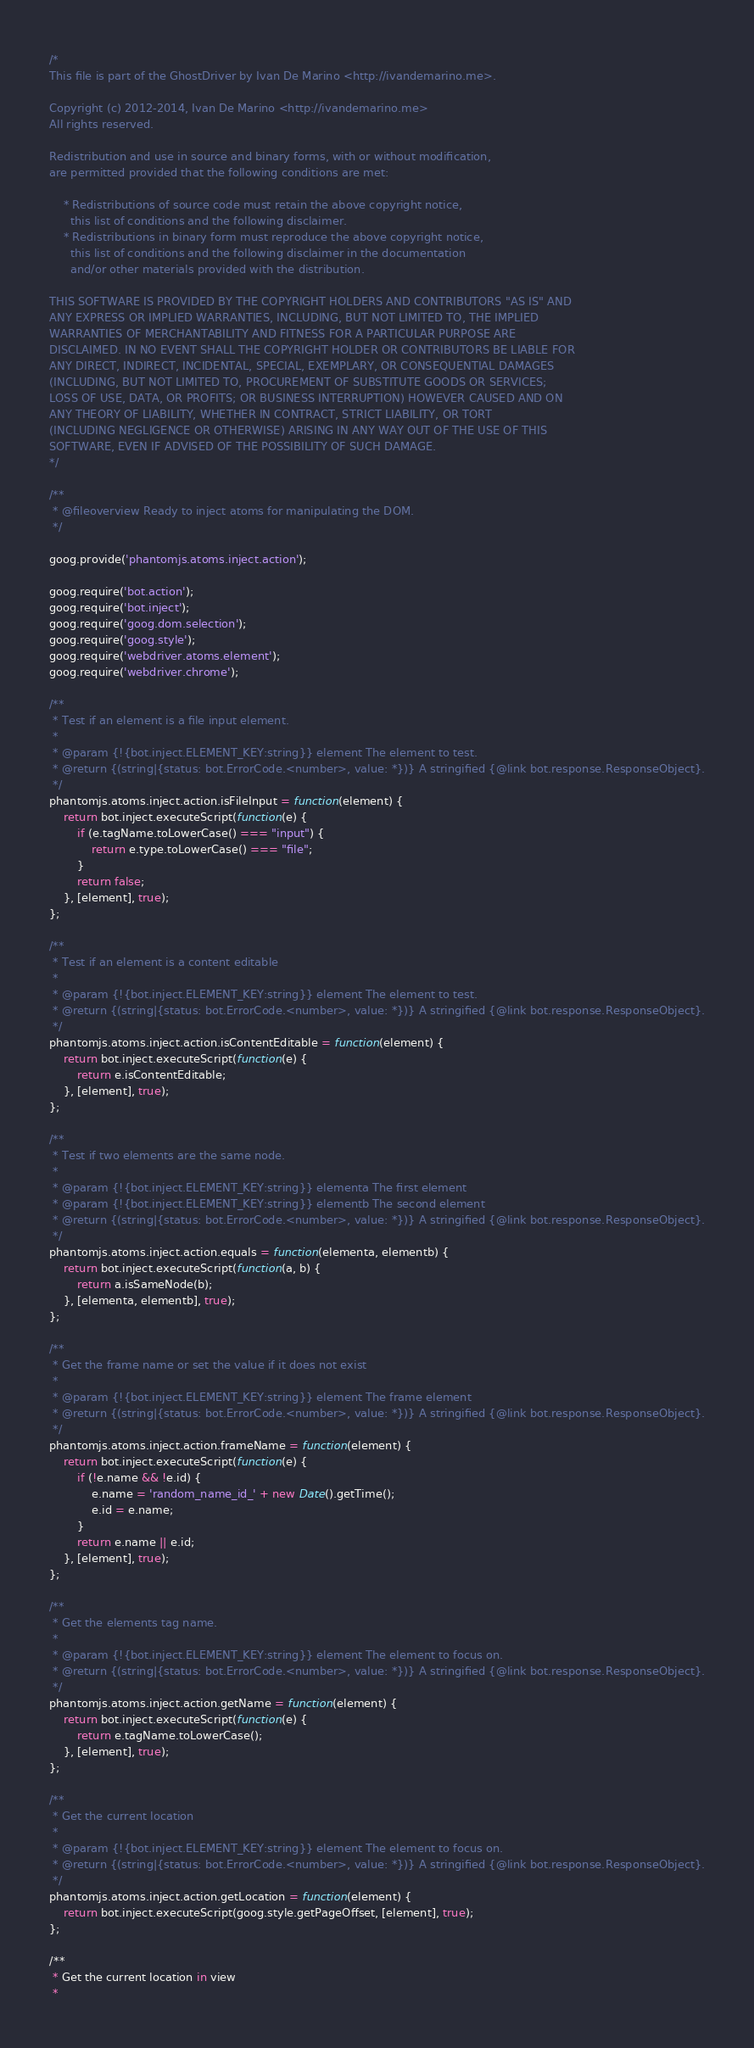<code> <loc_0><loc_0><loc_500><loc_500><_JavaScript_>/*
This file is part of the GhostDriver by Ivan De Marino <http://ivandemarino.me>.

Copyright (c) 2012-2014, Ivan De Marino <http://ivandemarino.me>
All rights reserved.

Redistribution and use in source and binary forms, with or without modification,
are permitted provided that the following conditions are met:

    * Redistributions of source code must retain the above copyright notice,
      this list of conditions and the following disclaimer.
    * Redistributions in binary form must reproduce the above copyright notice,
      this list of conditions and the following disclaimer in the documentation
      and/or other materials provided with the distribution.

THIS SOFTWARE IS PROVIDED BY THE COPYRIGHT HOLDERS AND CONTRIBUTORS "AS IS" AND
ANY EXPRESS OR IMPLIED WARRANTIES, INCLUDING, BUT NOT LIMITED TO, THE IMPLIED
WARRANTIES OF MERCHANTABILITY AND FITNESS FOR A PARTICULAR PURPOSE ARE
DISCLAIMED. IN NO EVENT SHALL THE COPYRIGHT HOLDER OR CONTRIBUTORS BE LIABLE FOR
ANY DIRECT, INDIRECT, INCIDENTAL, SPECIAL, EXEMPLARY, OR CONSEQUENTIAL DAMAGES
(INCLUDING, BUT NOT LIMITED TO, PROCUREMENT OF SUBSTITUTE GOODS OR SERVICES;
LOSS OF USE, DATA, OR PROFITS; OR BUSINESS INTERRUPTION) HOWEVER CAUSED AND ON
ANY THEORY OF LIABILITY, WHETHER IN CONTRACT, STRICT LIABILITY, OR TORT
(INCLUDING NEGLIGENCE OR OTHERWISE) ARISING IN ANY WAY OUT OF THE USE OF THIS
SOFTWARE, EVEN IF ADVISED OF THE POSSIBILITY OF SUCH DAMAGE.
*/

/**
 * @fileoverview Ready to inject atoms for manipulating the DOM.
 */

goog.provide('phantomjs.atoms.inject.action');

goog.require('bot.action');
goog.require('bot.inject');
goog.require('goog.dom.selection');
goog.require('goog.style');
goog.require('webdriver.atoms.element');
goog.require('webdriver.chrome');

/**
 * Test if an element is a file input element.
 *
 * @param {!{bot.inject.ELEMENT_KEY:string}} element The element to test.
 * @return {(string|{status: bot.ErrorCode.<number>, value: *})} A stringified {@link bot.response.ResponseObject}.
 */
phantomjs.atoms.inject.action.isFileInput = function(element) {
    return bot.inject.executeScript(function(e) {
        if (e.tagName.toLowerCase() === "input") {
            return e.type.toLowerCase() === "file";
        }
        return false;
    }, [element], true);
};

/**
 * Test if an element is a content editable
 *
 * @param {!{bot.inject.ELEMENT_KEY:string}} element The element to test.
 * @return {(string|{status: bot.ErrorCode.<number>, value: *})} A stringified {@link bot.response.ResponseObject}.
 */
phantomjs.atoms.inject.action.isContentEditable = function(element) {
    return bot.inject.executeScript(function(e) {
        return e.isContentEditable;
    }, [element], true);
};

/**
 * Test if two elements are the same node.
 *
 * @param {!{bot.inject.ELEMENT_KEY:string}} elementa The first element
 * @param {!{bot.inject.ELEMENT_KEY:string}} elementb The second element
 * @return {(string|{status: bot.ErrorCode.<number>, value: *})} A stringified {@link bot.response.ResponseObject}.
 */
phantomjs.atoms.inject.action.equals = function(elementa, elementb) {
    return bot.inject.executeScript(function(a, b) {
        return a.isSameNode(b);
    }, [elementa, elementb], true);
};

/**
 * Get the frame name or set the value if it does not exist
 *
 * @param {!{bot.inject.ELEMENT_KEY:string}} element The frame element
 * @return {(string|{status: bot.ErrorCode.<number>, value: *})} A stringified {@link bot.response.ResponseObject}.
 */
phantomjs.atoms.inject.action.frameName = function(element) {
    return bot.inject.executeScript(function(e) {
        if (!e.name && !e.id) {
            e.name = 'random_name_id_' + new Date().getTime();
            e.id = e.name;
        }
        return e.name || e.id;
    }, [element], true);
};

/**
 * Get the elements tag name.
 *
 * @param {!{bot.inject.ELEMENT_KEY:string}} element The element to focus on.
 * @return {(string|{status: bot.ErrorCode.<number>, value: *})} A stringified {@link bot.response.ResponseObject}.
 */
phantomjs.atoms.inject.action.getName = function(element) {
    return bot.inject.executeScript(function(e) {
        return e.tagName.toLowerCase();
    }, [element], true);
};

/**
 * Get the current location
 *
 * @param {!{bot.inject.ELEMENT_KEY:string}} element The element to focus on.
 * @return {(string|{status: bot.ErrorCode.<number>, value: *})} A stringified {@link bot.response.ResponseObject}.
 */
phantomjs.atoms.inject.action.getLocation = function(element) {
    return bot.inject.executeScript(goog.style.getPageOffset, [element], true);
};

/**
 * Get the current location in view
 *</code> 